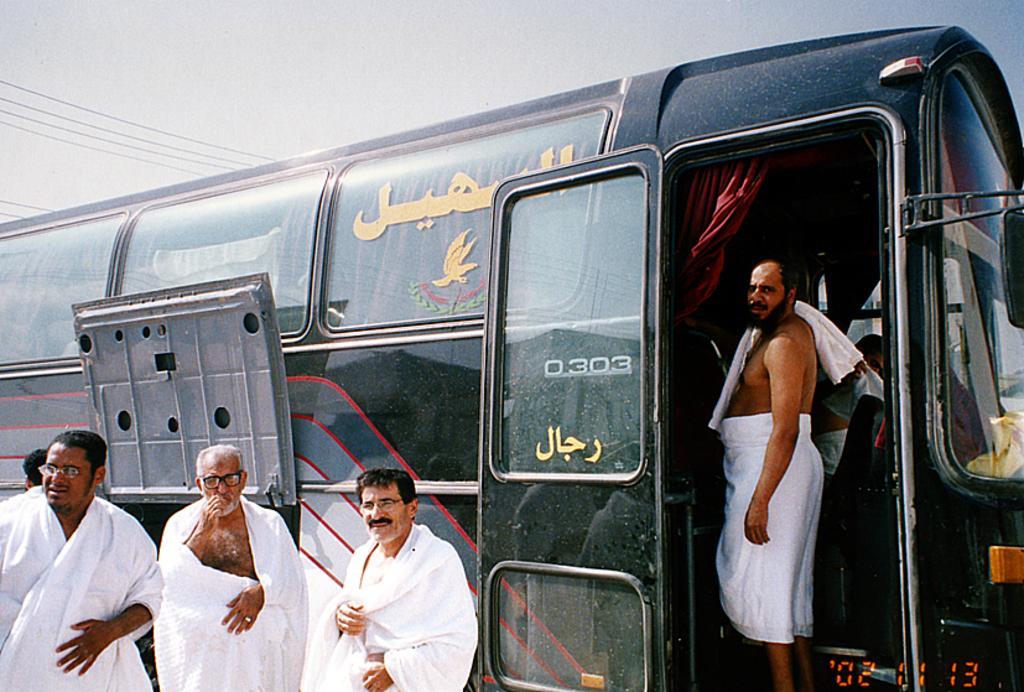Could you give a brief overview of what you see in this image? At the top we can see the sky and wires. In this picture we can see a vehicle and a man is standing and another person is visible. We can see a red curtain. We can see men wearing spectacles and standing near to a vehicle. We can see another person behind them. In the bottom right corner we can see the digits. 